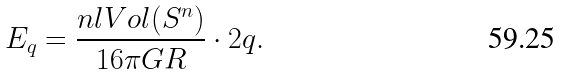<formula> <loc_0><loc_0><loc_500><loc_500>E _ { q } = \frac { n l V o l ( S ^ { n } ) } { 1 6 \pi G R } \cdot 2 q .</formula> 